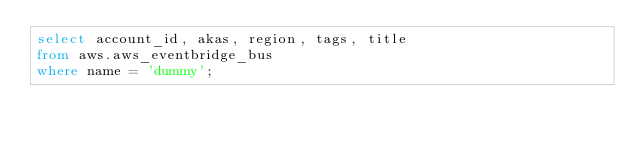<code> <loc_0><loc_0><loc_500><loc_500><_SQL_>select account_id, akas, region, tags, title
from aws.aws_eventbridge_bus
where name = 'dummy';
 </code> 